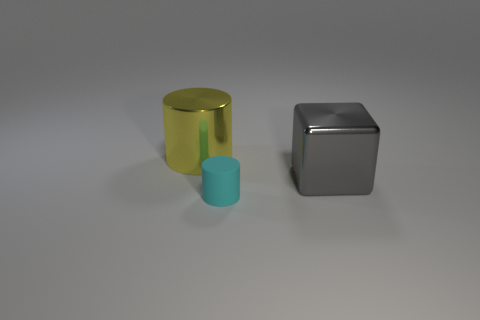There is a metal cylinder that is behind the big gray metallic block; what color is it?
Your answer should be compact. Yellow. There is a big metallic object that is right of the thing behind the gray thing; how many yellow cylinders are to the left of it?
Your response must be concise. 1. The thing that is to the left of the large gray thing and in front of the yellow metal cylinder is made of what material?
Ensure brevity in your answer.  Rubber. Does the yellow cylinder have the same material as the big thing that is right of the matte cylinder?
Your answer should be very brief. Yes. Is the number of yellow shiny cylinders that are left of the big yellow cylinder greater than the number of matte cylinders that are behind the metallic cube?
Make the answer very short. No. What is the shape of the gray shiny object?
Offer a terse response. Cube. Is the big thing that is on the right side of the tiny cyan cylinder made of the same material as the cylinder that is behind the gray metal thing?
Make the answer very short. Yes. There is a metal object in front of the big yellow thing; what shape is it?
Give a very brief answer. Cube. The yellow metal object that is the same shape as the matte object is what size?
Ensure brevity in your answer.  Large. Is the color of the small object the same as the big metal cylinder?
Provide a short and direct response. No. 